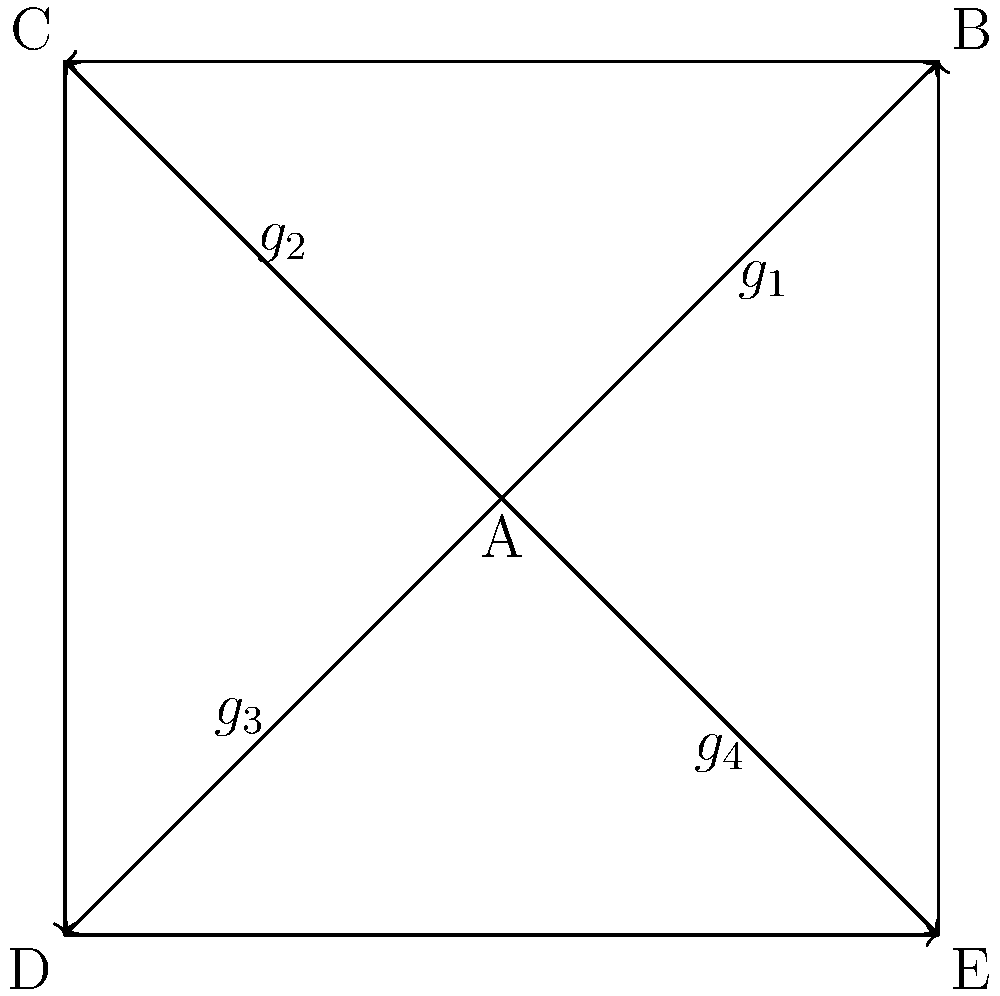Consider the Cayley graph representation of a piracy network structure shown above. The graph has 5 vertices (A, B, C, D, E) representing different roles in the network, and 4 generators ($g_1$, $g_2$, $g_3$, $g_4$) representing different types of connections. What is the order of the group represented by this Cayley graph, and what implications does this have for the resilience of the piracy network? To answer this question, we need to follow these steps:

1. Understand the Cayley graph:
   - The vertices represent group elements (roles in the piracy network).
   - The edges represent the action of generators (types of connections).

2. Determine the order of the group:
   - The order of a group is the number of elements in the group.
   - In a Cayley graph, this corresponds to the number of vertices.
   - We can count 5 vertices (A, B, C, D, E) in the given graph.

3. Analyze the implications for network resilience:
   - A higher order generally implies a more complex network structure.
   - The presence of multiple generators ($g_1$, $g_2$, $g_3$, $g_4$) suggests diverse connection types.
   - The graph is connected, indicating that all roles can communicate with each other through some combination of connections.

4. Consider the socioeconomic factors:
   - The relatively small order (5) might indicate a localized or specialized piracy operation.
   - The multiple connection types could represent different socioeconomic relationships (e.g., financial, logistical, informational).

5. Evaluate resilience:
   - The small size makes the network vulnerable to disruption if any single node is removed.
   - However, the multiple connection types (generators) provide redundancy, potentially increasing resilience.
   - The cyclic structure (B-C-D-E-B) suggests that even if the central node (A) is removed, the remaining nodes can still communicate.

In conclusion, the order of the group is 5, representing a small but interconnected piracy network. This structure suggests a network that is vulnerable due to its size but has some resilience due to its diverse connections and cyclic nature.
Answer: Order: 5. Implications: Small, vulnerable network with some resilience due to diverse connections and cyclic structure. 